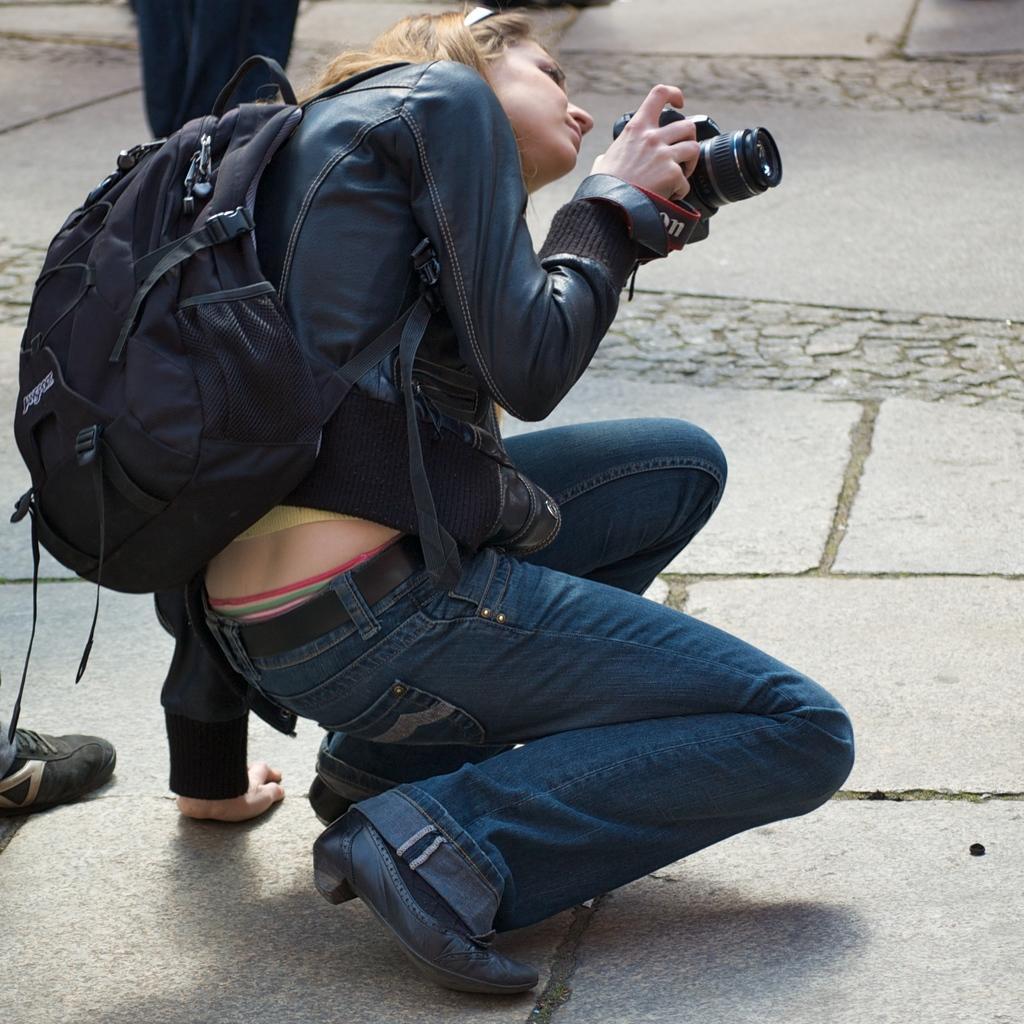Could you give a brief overview of what you see in this image? This image consists of a person who is sitting. She is holding a camera, she also has bag ,she is wearing black color jacket and blue color jeans with black shoes. A person's shoe is visible on the left side. 